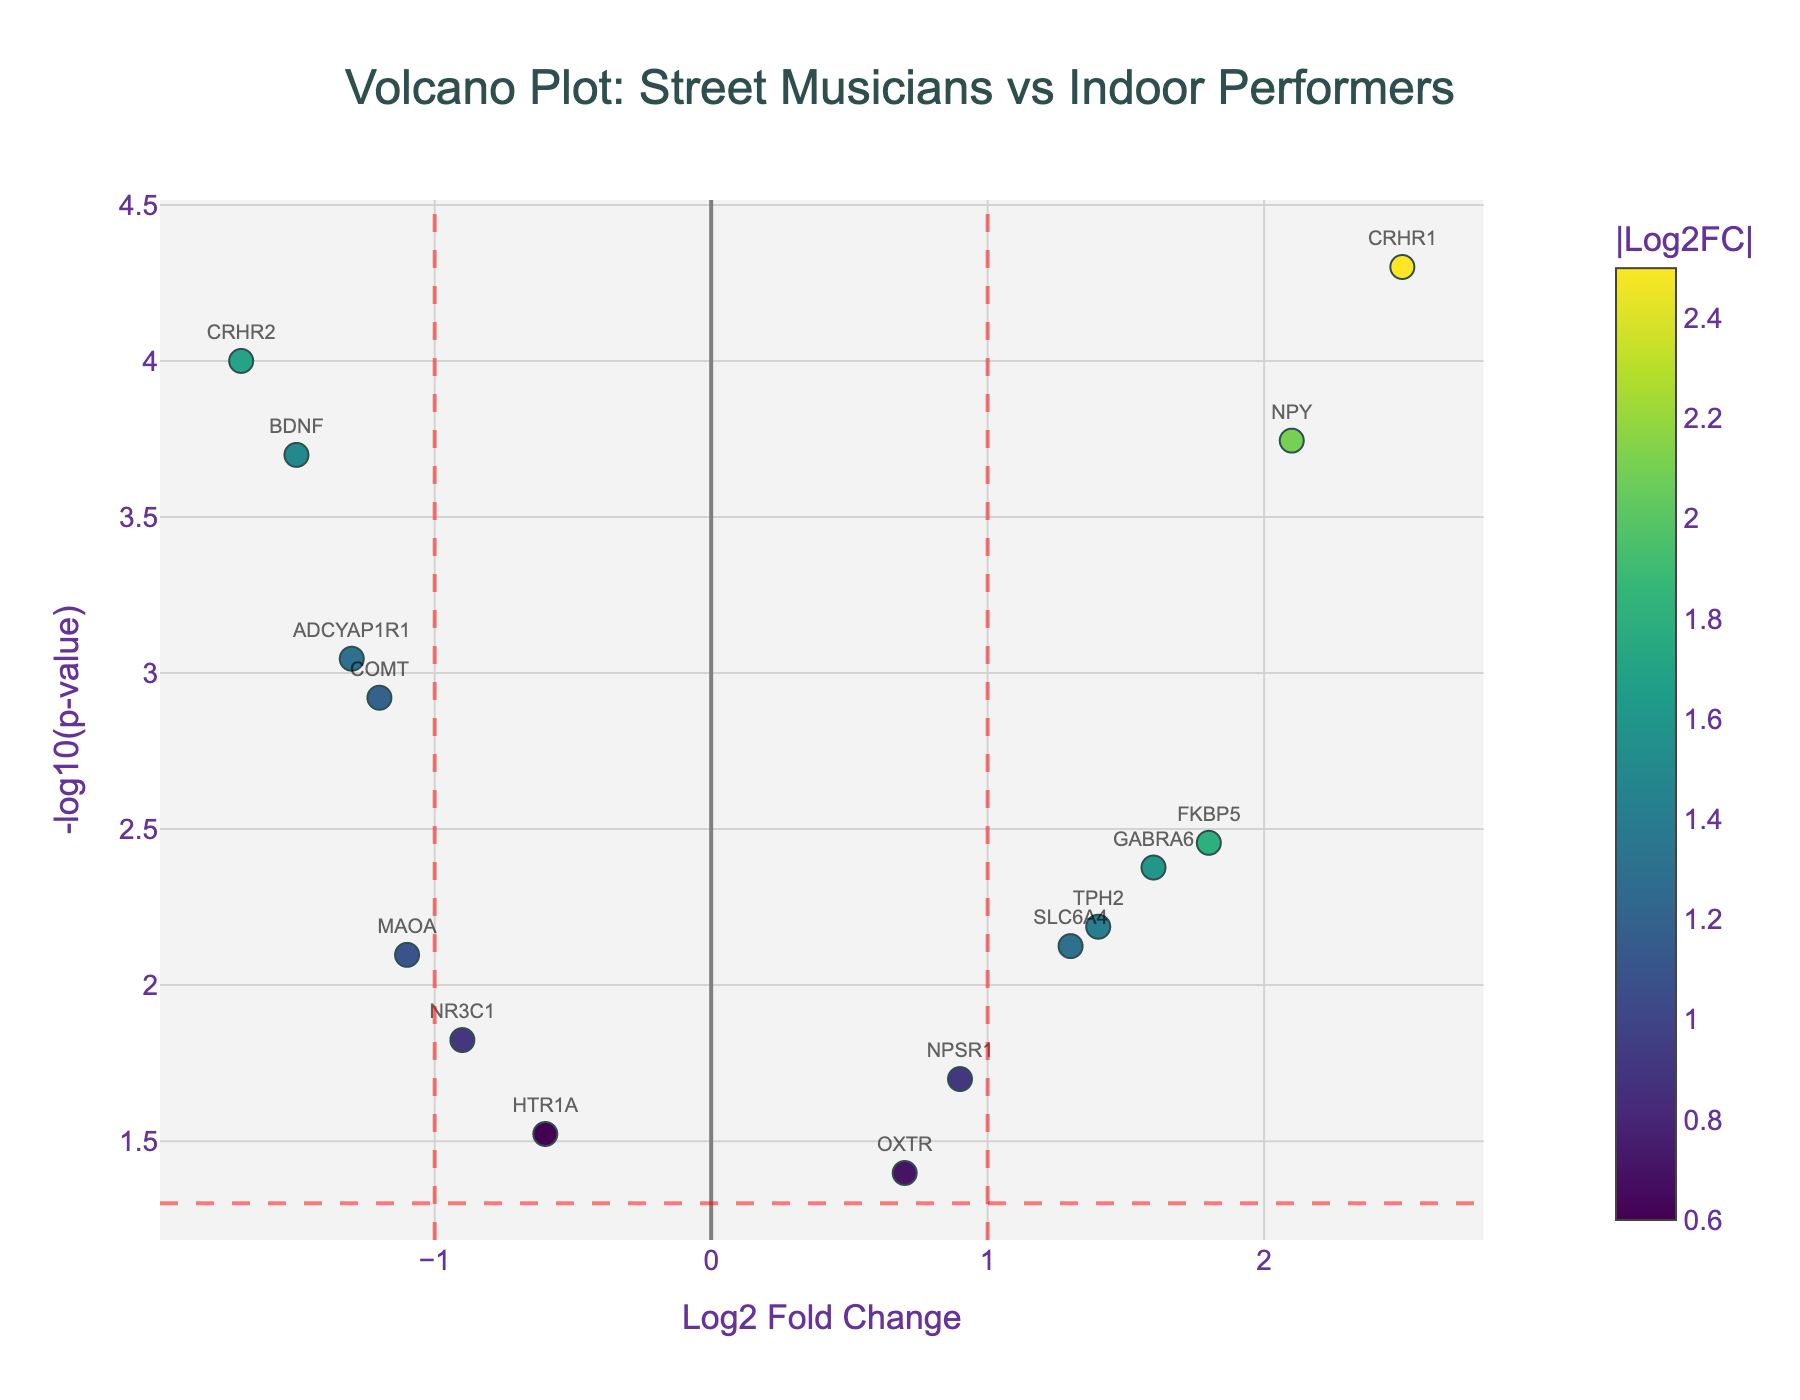What's the title of the figure? The title is displayed at the top of the figure. It reads "Volcano Plot: Street Musicians vs Indoor Performers".
Answer: Volcano Plot: Street Musicians vs Indoor Performers What are the labels of the x-axis and y-axis? The labels are displayed alongside each axis. The x-axis label is "Log2 Fold Change", and the y-axis label is "-log10(p-value)".
Answer: Log2 Fold Change and -log10(p-value) How many genes show a positive Log2 Fold Change greater than 1? Look for data points with Log2FC > 1. These (CRHR1, FKBP5, SLC6A4, NPY, GABRA6, TPH2) are above this threshold. Count the genes listed.
Answer: 6 Which gene has the smallest p-value and what is its Log2 Fold Change? Find the data point with the smallest p-value (highest -log10(p-value)). CRHR1 has the smallest p-value (0.00005) with a Log2FC of 2.5.
Answer: CRHR1, 2.5 Which genes have a negative Log2 Fold Change and a p-value less than 0.005? Identify genes with Log2FC < 0 and P-value < 0.005. These are COMT, BDNF, CRHR2, and ADCYAP1R1.
Answer: COMT, BDNF, CRHR2, ADCYAP1R1 What gene has the largest negative Log2 Fold Change and what is its p-value? Find the data point with the most negative Log2FC. CRHR2 has Log2FC of -1.7 with a p-value of 0.0001.
Answer: CRHR2, 0.0001 How many genes have a -log10(p-value) greater than 2? Calculate -log10(0.01) to determine the threshold for the p-value. Genes with -log10(p-value) > 2 are COMT, CRHR1, FKBP5, BDNF, NPY, CRHR2, and ADCYAP1R1. Count these genes.
Answer: 7 Which gene shows a Log2 Fold Change of approximately 1.6? Look for a gene with Log2FC around 1.6. GABRA6 matches this description.
Answer: GABRA6 Are there any genes with a Log2 Fold Change lower than -1 and a -log10(p-value) lower than 2? Observe data points with Log2FC < -1 and -log10(p-value) < 2. MAOA is the only gene meeting these criteria.
Answer: MAOA 